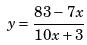<formula> <loc_0><loc_0><loc_500><loc_500>y = \frac { 8 3 - 7 x } { 1 0 x + 3 }</formula> 